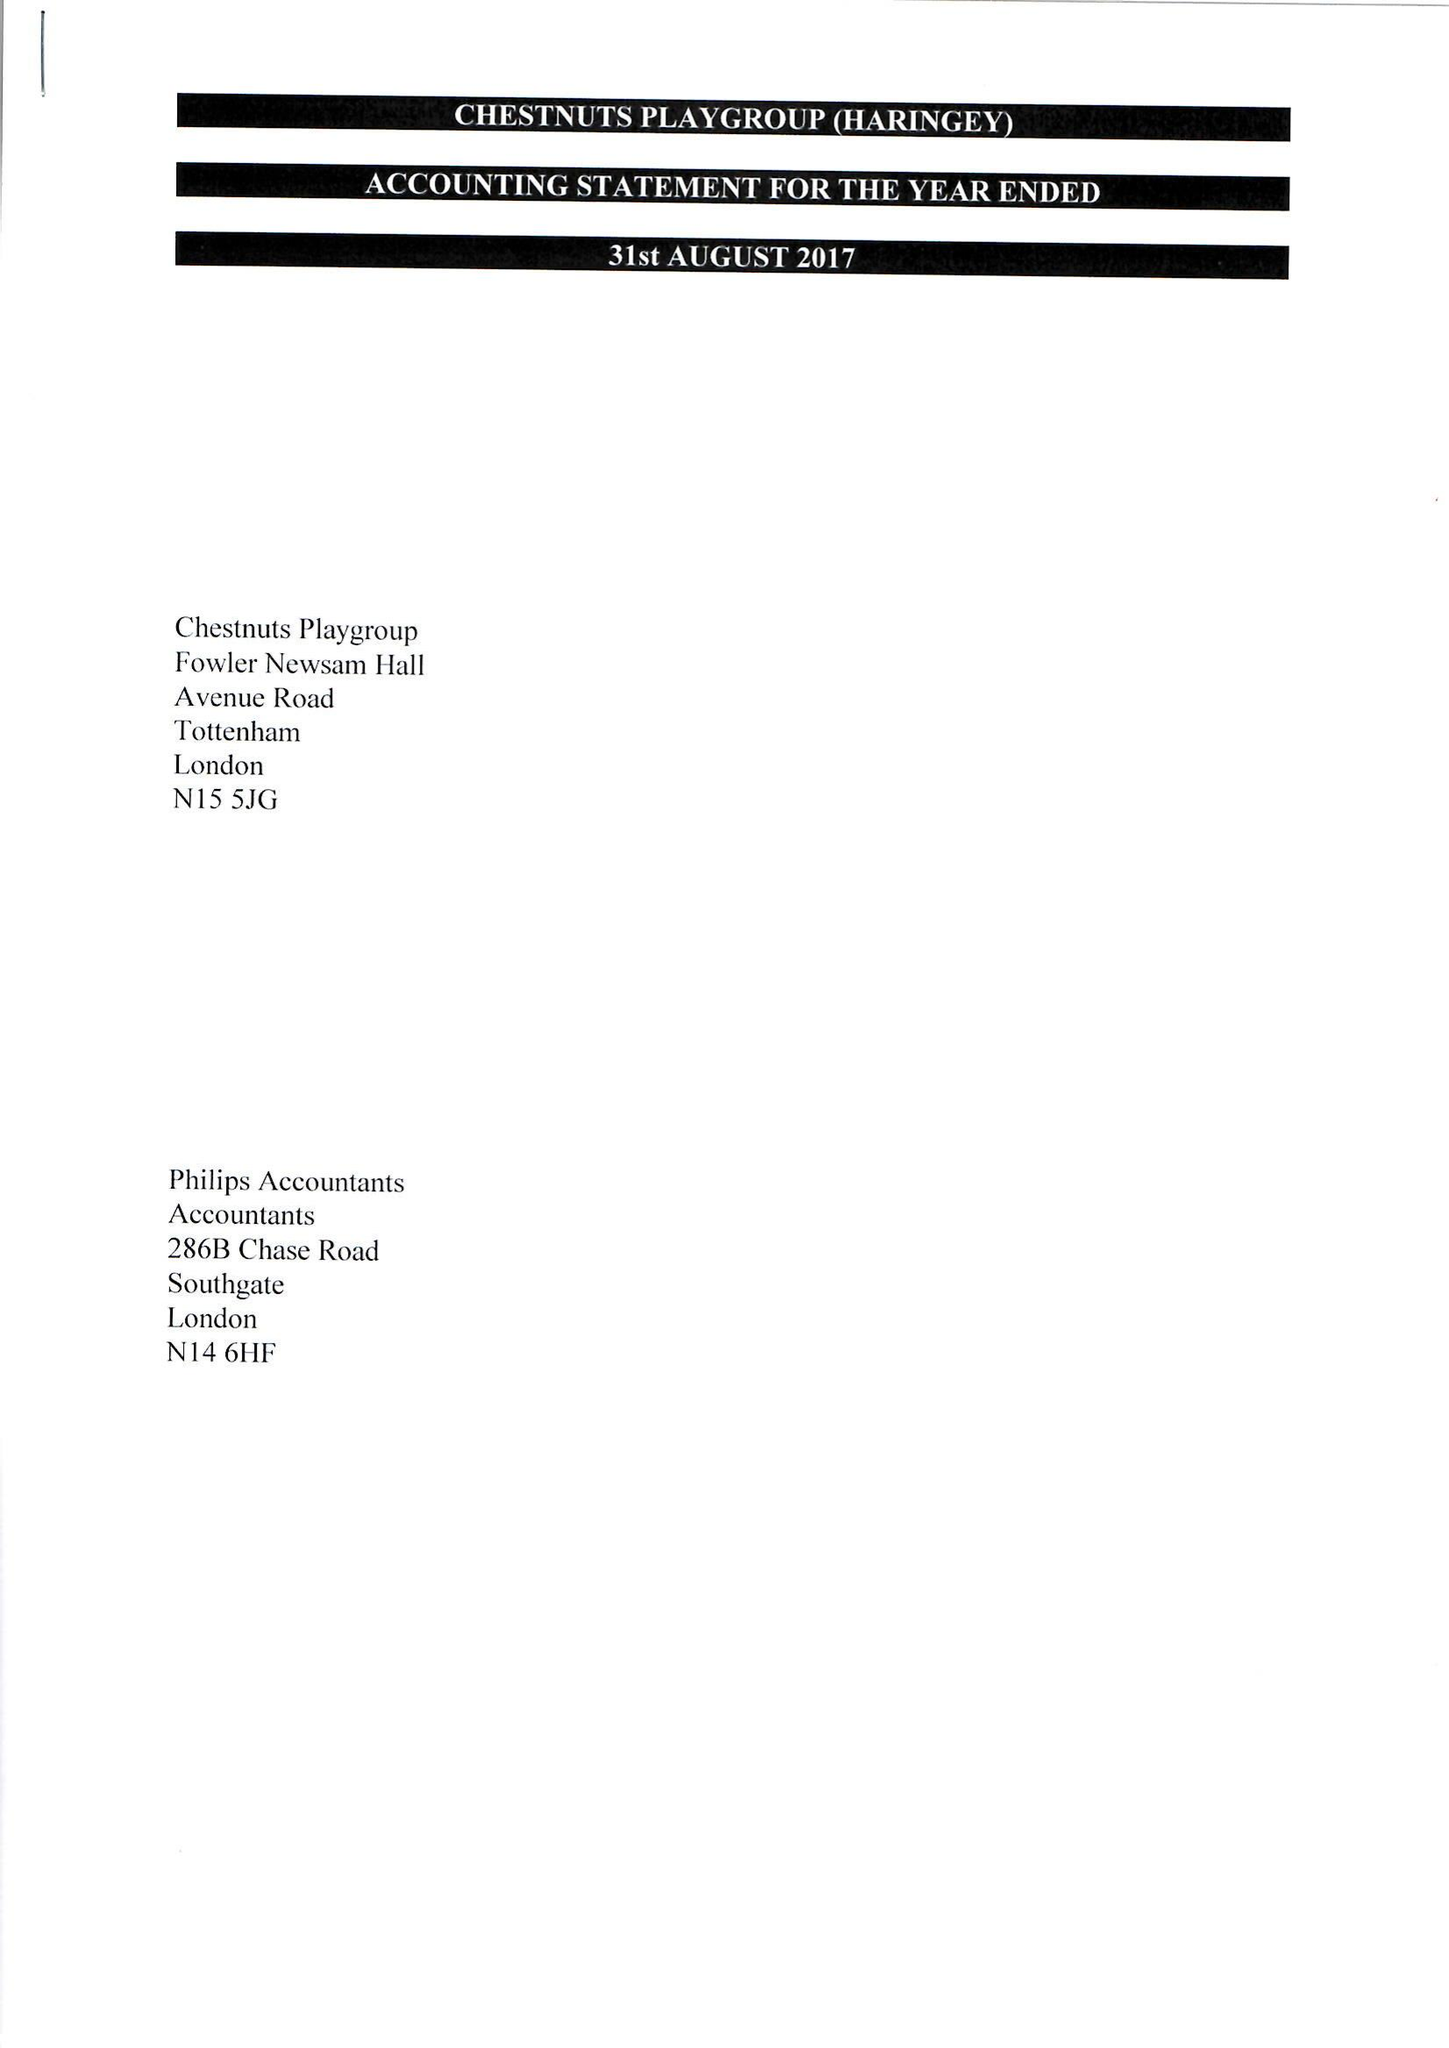What is the value for the income_annually_in_british_pounds?
Answer the question using a single word or phrase. 131438.00 